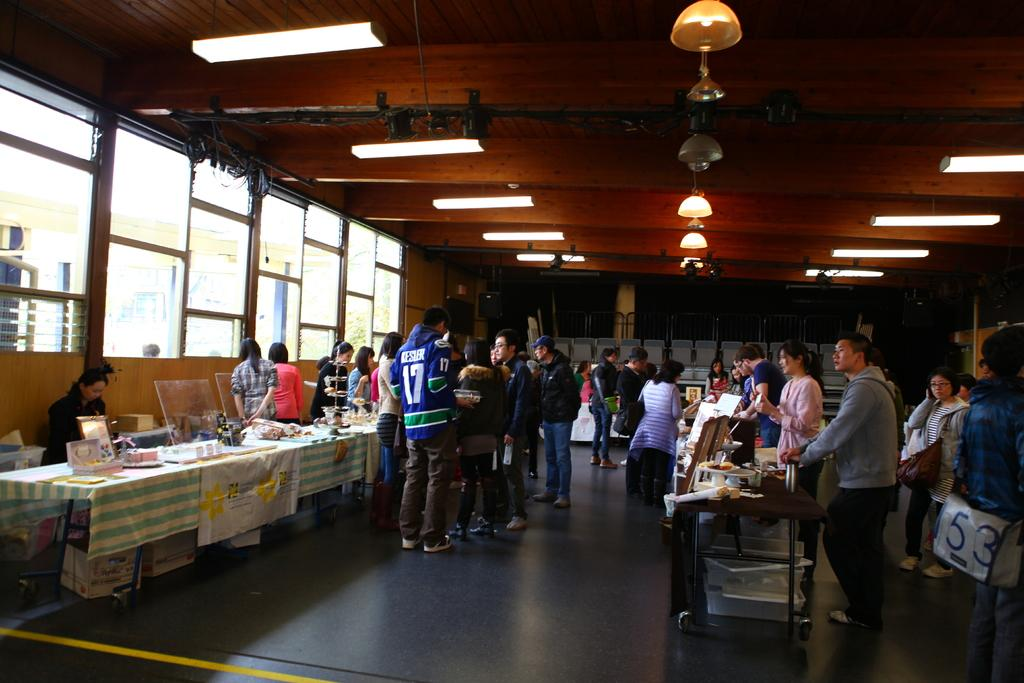How many people are in the image? There is a group of people in the image. What are the people doing in the image? The people are standing. What objects are in front of the people? There are boxes in front of the people. What else can be seen on the tables in the image? There are other things on the tables. What is positioned above the tables in the image? There are lights on top of the tables. What is the name of the actor who plays the lead role in the image? There is no actor or lead role in the image; it is a group of people standing with boxes and other items on tables. 